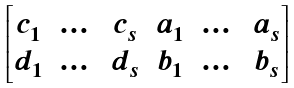<formula> <loc_0><loc_0><loc_500><loc_500>\begin{bmatrix} c _ { 1 } & \dots & c _ { s } & a _ { 1 } & \dots & a _ { s } \\ d _ { 1 } & \dots & d _ { s } & b _ { 1 } & \dots & b _ { s } \end{bmatrix}</formula> 